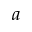Convert formula to latex. <formula><loc_0><loc_0><loc_500><loc_500>a</formula> 